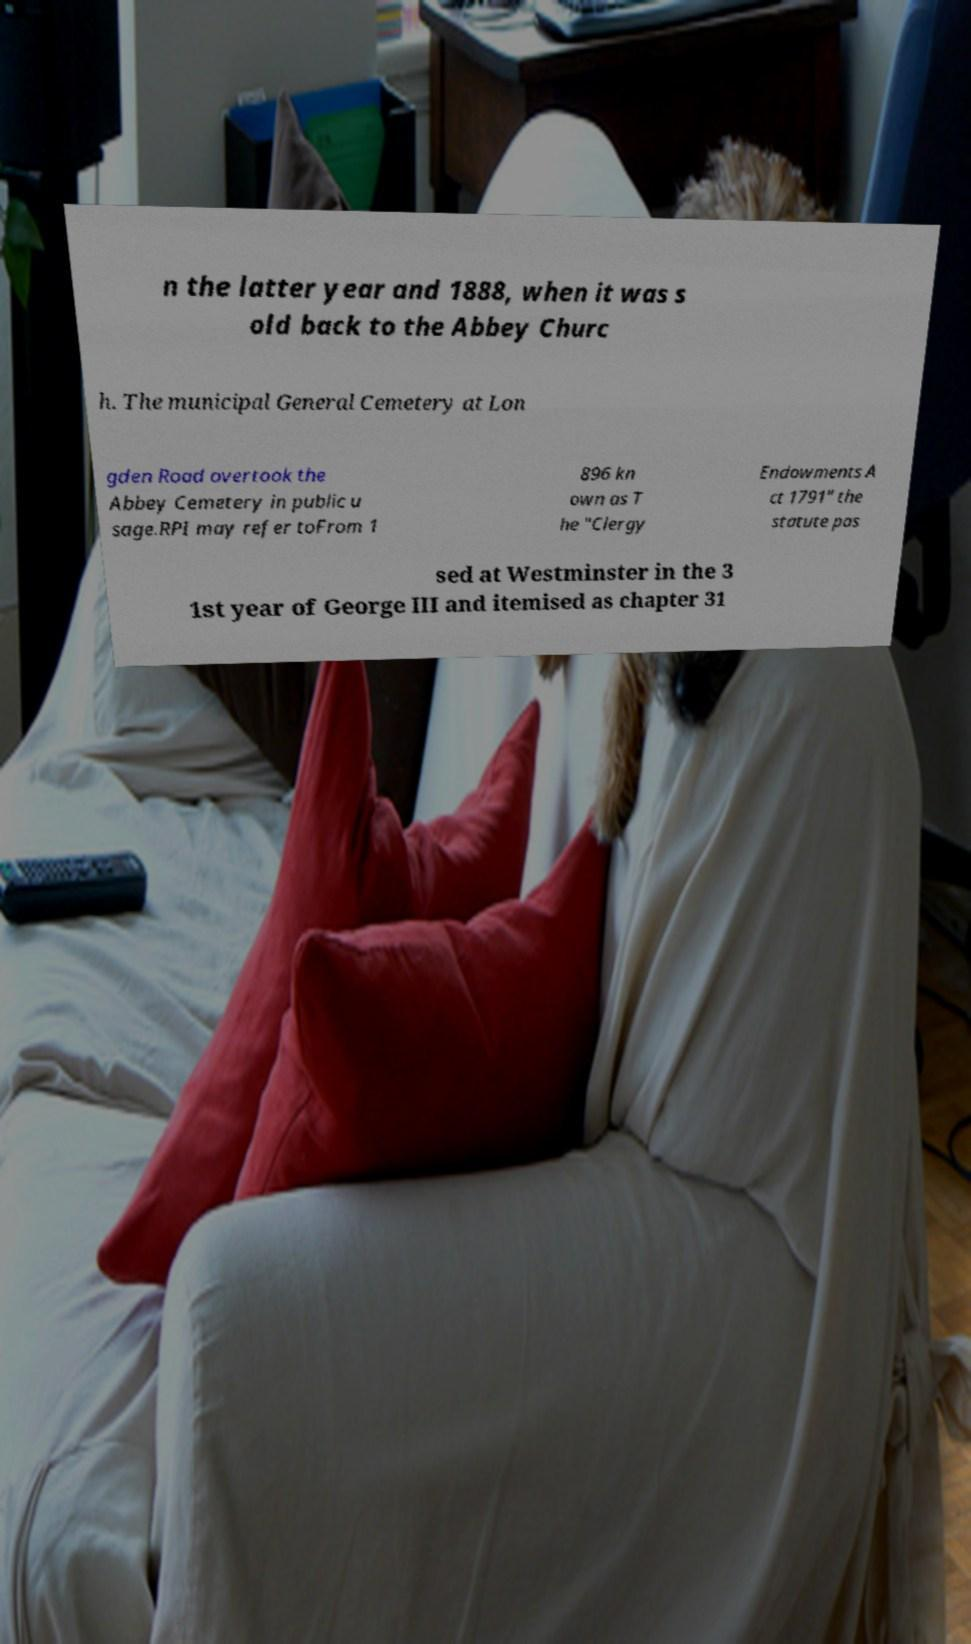Please read and relay the text visible in this image. What does it say? n the latter year and 1888, when it was s old back to the Abbey Churc h. The municipal General Cemetery at Lon gden Road overtook the Abbey Cemetery in public u sage.RPI may refer toFrom 1 896 kn own as T he "Clergy Endowments A ct 1791" the statute pas sed at Westminster in the 3 1st year of George III and itemised as chapter 31 